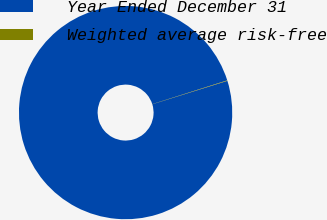<chart> <loc_0><loc_0><loc_500><loc_500><pie_chart><fcel>Year Ended December 31<fcel>Weighted average risk-free<nl><fcel>99.93%<fcel>0.07%<nl></chart> 